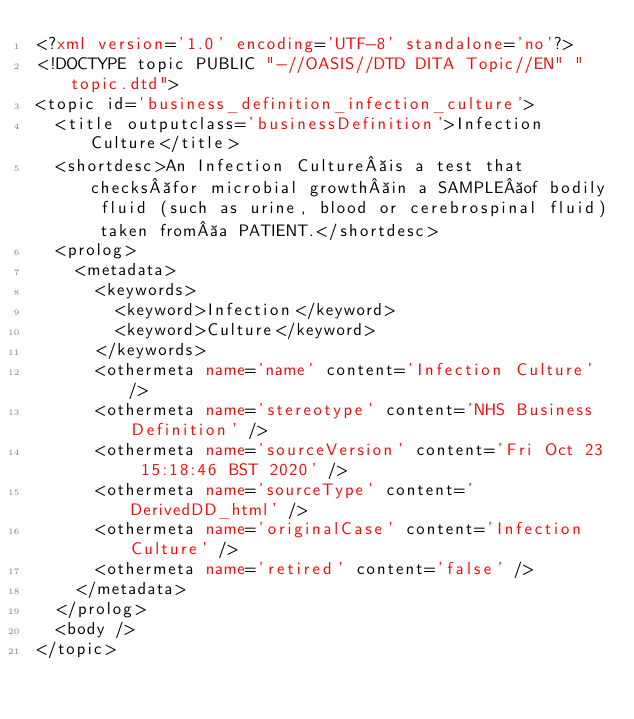Convert code to text. <code><loc_0><loc_0><loc_500><loc_500><_XML_><?xml version='1.0' encoding='UTF-8' standalone='no'?>
<!DOCTYPE topic PUBLIC "-//OASIS//DTD DITA Topic//EN" "topic.dtd">
<topic id='business_definition_infection_culture'>
  <title outputclass='businessDefinition'>Infection Culture</title>
  <shortdesc>An Infection Culture is a test that checks for microbial growth in a SAMPLE of bodily fluid (such as urine, blood or cerebrospinal fluid) taken from a PATIENT.</shortdesc>
  <prolog>
    <metadata>
      <keywords>
        <keyword>Infection</keyword>
        <keyword>Culture</keyword>
      </keywords>
      <othermeta name='name' content='Infection Culture' />
      <othermeta name='stereotype' content='NHS Business Definition' />
      <othermeta name='sourceVersion' content='Fri Oct 23 15:18:46 BST 2020' />
      <othermeta name='sourceType' content='DerivedDD_html' />
      <othermeta name='originalCase' content='Infection Culture' />
      <othermeta name='retired' content='false' />
    </metadata>
  </prolog>
  <body />
</topic></code> 